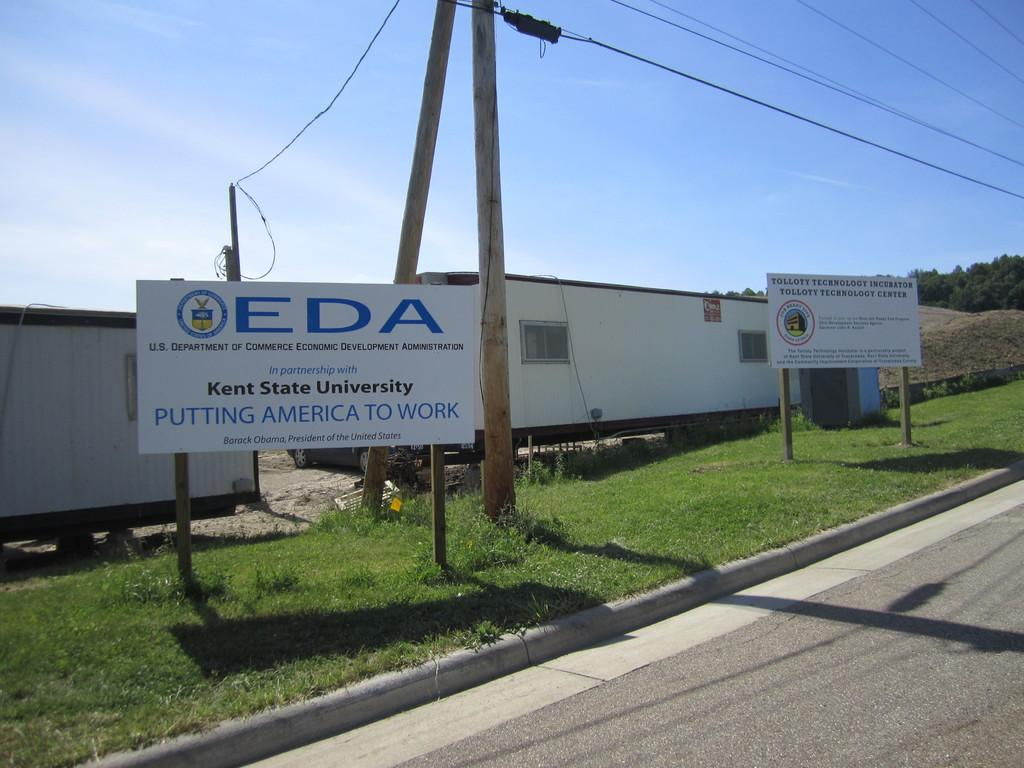What objects are present in the image that are used for storage or transportation? There are containers in the image. What objects are present in the image that provide information or directions? There are information boards in the image. What objects are present in the image that are related to electrical infrastructure? There are poles with wires in the image. What type of vegetation is visible in the image? There are trees and grass in the image. What type of man-made surface is visible in the image? There is a road in the image. What part of the natural environment is visible in the image? The sky is visible in the image. What type of blood is visible on the pump in the image? There is no blood or pump present in the image. What type of steel is used to construct the buildings in the image? There are no buildings or steel mentioned in the image. 